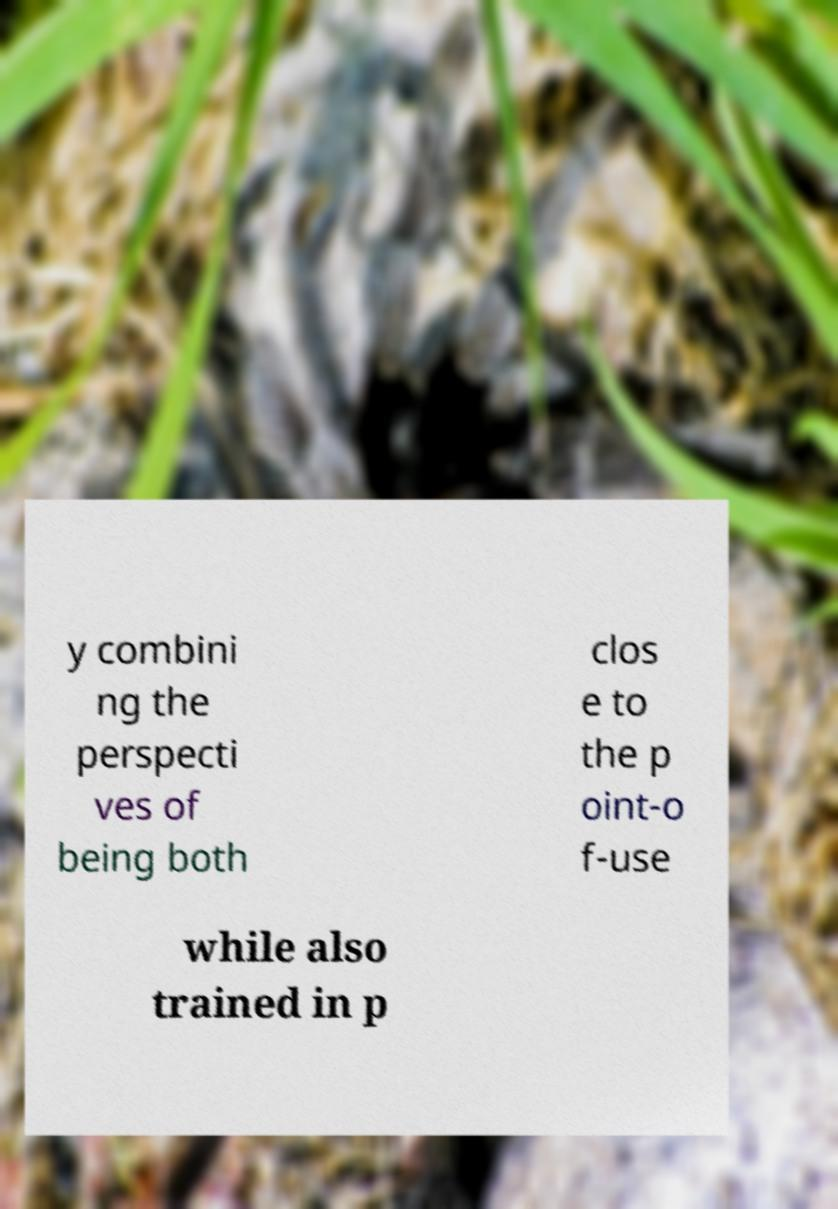Could you assist in decoding the text presented in this image and type it out clearly? y combini ng the perspecti ves of being both clos e to the p oint-o f-use while also trained in p 